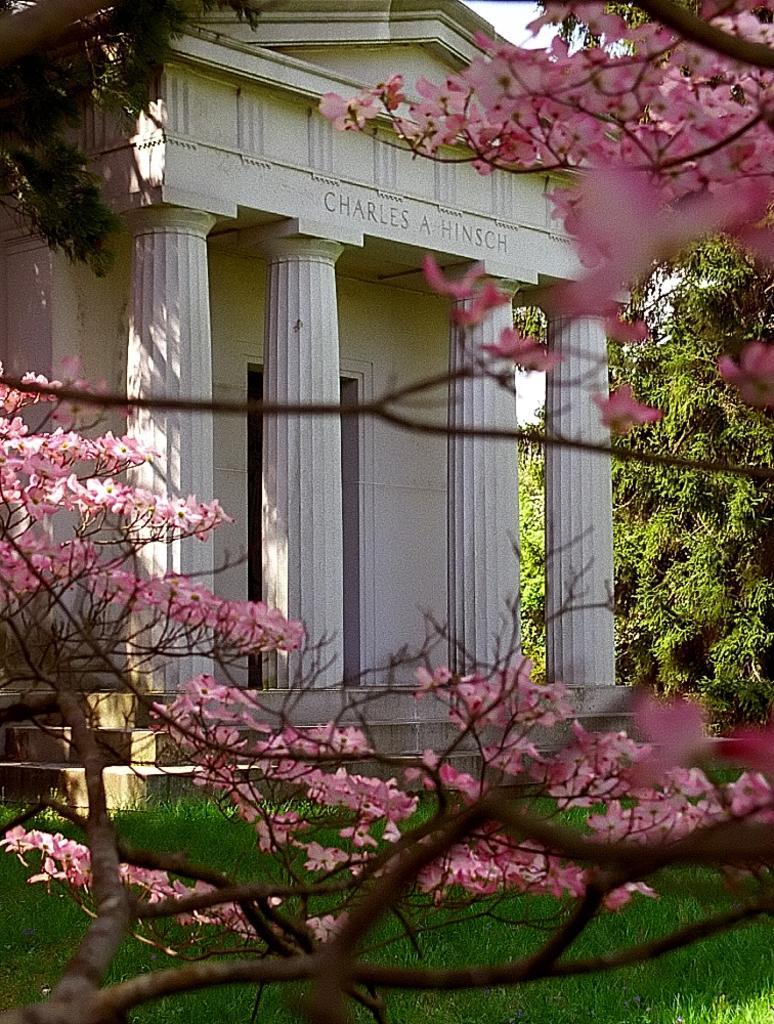Could you give a brief overview of what you see in this image? In this image there is a building and we can see trees. There are flowers. At the bottom there is grass. In the background there is sky. 